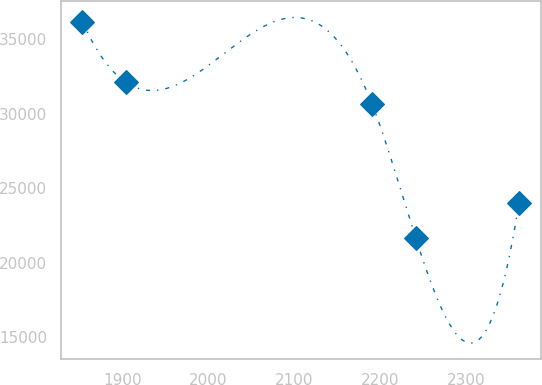Convert chart to OTSL. <chart><loc_0><loc_0><loc_500><loc_500><line_chart><ecel><fcel>Unnamed: 1<nl><fcel>1853.46<fcel>36181<nl><fcel>1904.2<fcel>32107.5<nl><fcel>2190.18<fcel>30658.4<nl><fcel>2240.92<fcel>21689.7<nl><fcel>2360.87<fcel>23986.8<nl></chart> 